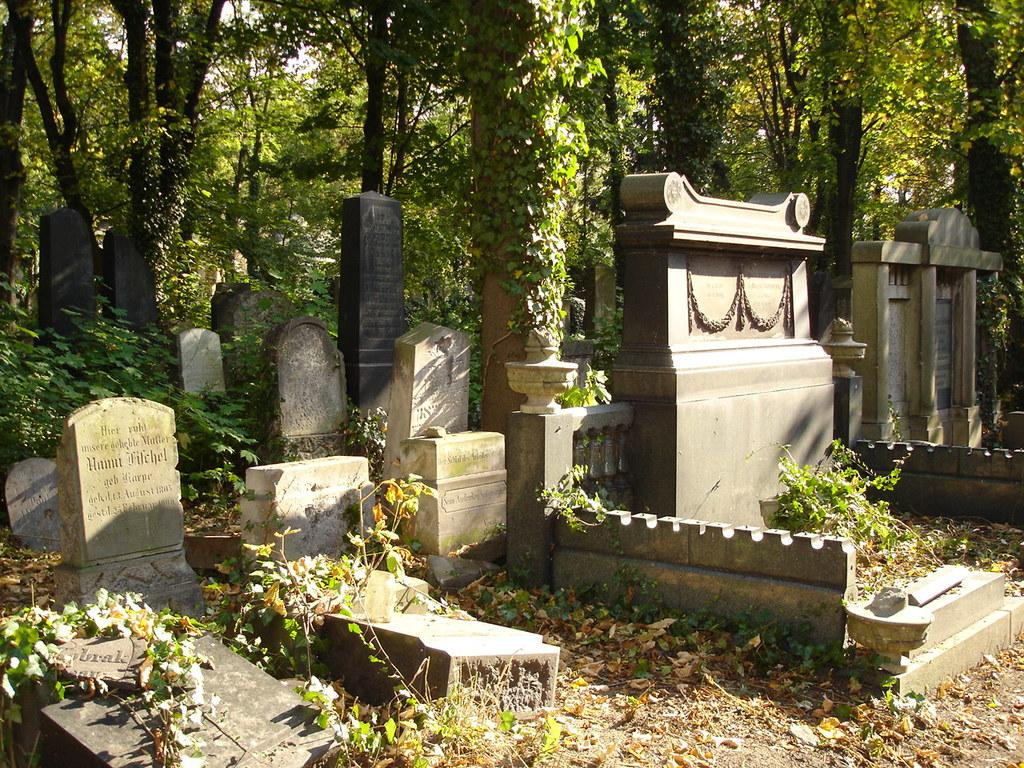What is the main subject of the image? The main subject of the image is a graveyard. What can be seen in the background of the image? Trees are visible in the background of the image. Can you see a baby playing with a bat in the image? No, there is no baby or bat present in the image; it features a graveyard and trees in the background. 